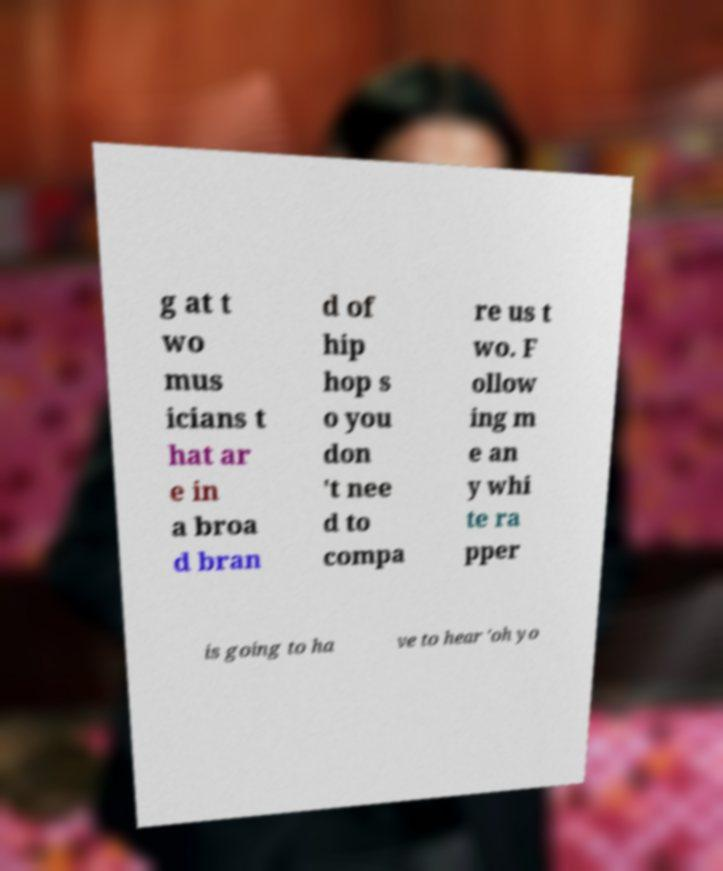I need the written content from this picture converted into text. Can you do that? g at t wo mus icians t hat ar e in a broa d bran d of hip hop s o you don 't nee d to compa re us t wo. F ollow ing m e an y whi te ra pper is going to ha ve to hear 'oh yo 